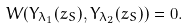Convert formula to latex. <formula><loc_0><loc_0><loc_500><loc_500>W ( Y _ { \lambda _ { 1 } } ( z _ { S } ) , Y _ { \lambda _ { 2 } } ( z _ { S } ) ) = 0 .</formula> 